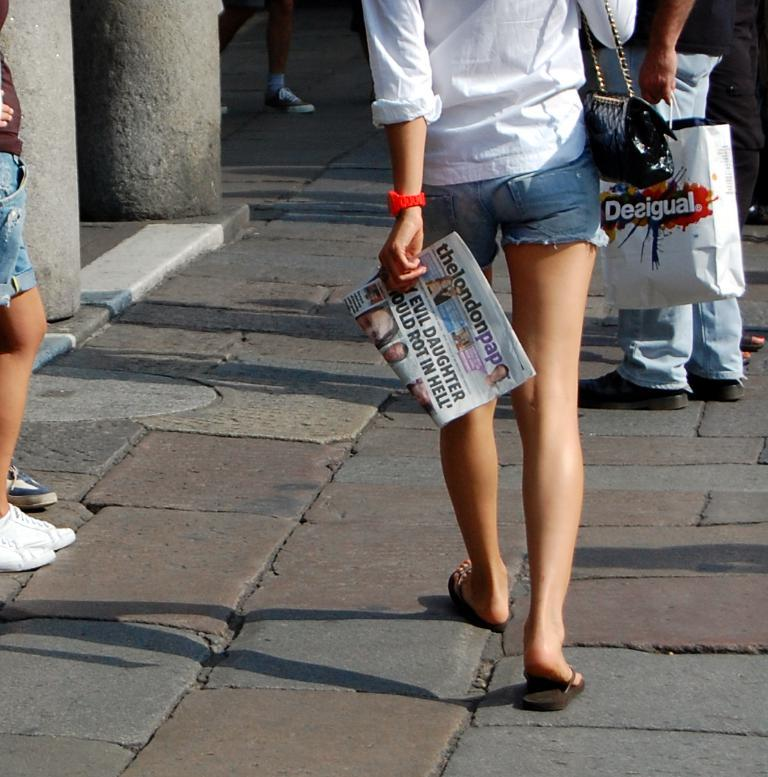How many people are in the image? There are four persons in the image. Where is the image taken? The image is taken on a road. What objects can be seen in the image besides the people? There is a paper and a bag in the image. What architectural feature is present in the image? There are pillars in the image. Can you tell if the image was taken during the day or night? The image is likely taken during the day, as there is no indication of darkness or artificial lighting. What type of plantation can be seen in the background of the image? There is no plantation visible in the image; it is taken on a road with pillars and no background plantation. 